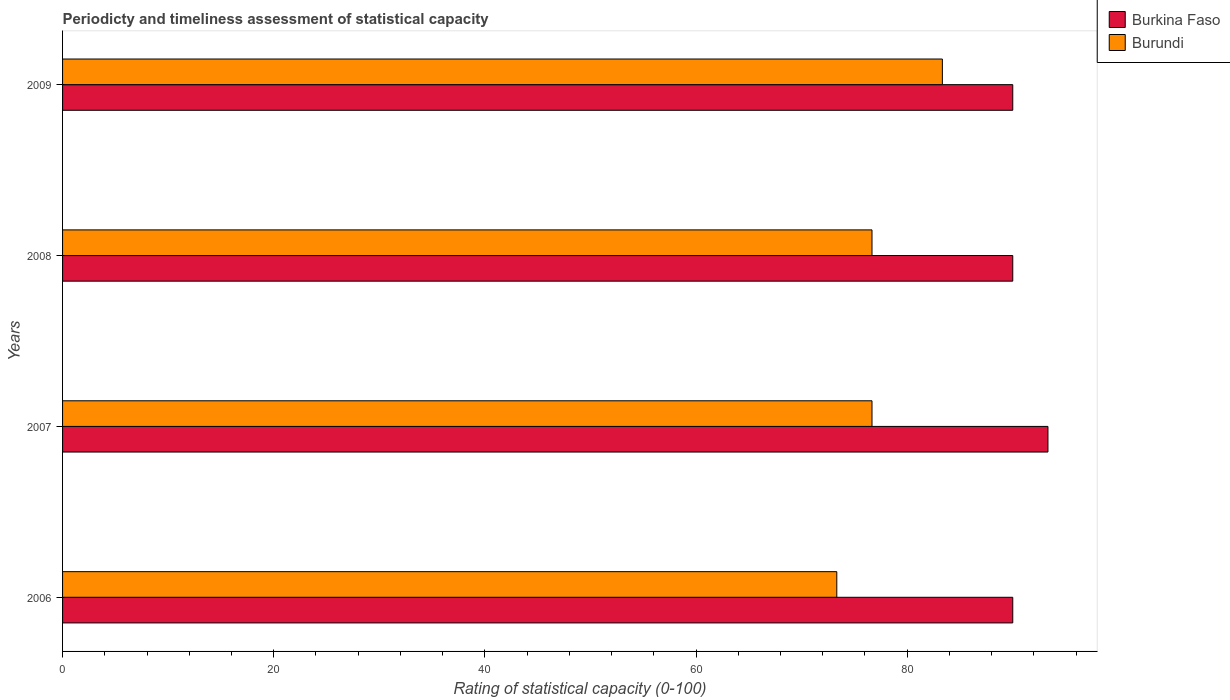How many groups of bars are there?
Your answer should be compact. 4. How many bars are there on the 3rd tick from the top?
Offer a terse response. 2. How many bars are there on the 4th tick from the bottom?
Provide a succinct answer. 2. What is the label of the 2nd group of bars from the top?
Offer a very short reply. 2008. In how many cases, is the number of bars for a given year not equal to the number of legend labels?
Provide a succinct answer. 0. Across all years, what is the maximum rating of statistical capacity in Burkina Faso?
Your response must be concise. 93.33. In which year was the rating of statistical capacity in Burkina Faso maximum?
Provide a short and direct response. 2007. What is the total rating of statistical capacity in Burkina Faso in the graph?
Provide a short and direct response. 363.33. What is the difference between the rating of statistical capacity in Burkina Faso in 2008 and that in 2009?
Keep it short and to the point. 0. What is the difference between the rating of statistical capacity in Burundi in 2008 and the rating of statistical capacity in Burkina Faso in 2007?
Give a very brief answer. -16.67. What is the average rating of statistical capacity in Burkina Faso per year?
Give a very brief answer. 90.83. In the year 2009, what is the difference between the rating of statistical capacity in Burundi and rating of statistical capacity in Burkina Faso?
Offer a terse response. -6.67. In how many years, is the rating of statistical capacity in Burundi greater than 76 ?
Your response must be concise. 3. What is the ratio of the rating of statistical capacity in Burundi in 2008 to that in 2009?
Offer a terse response. 0.92. Is the difference between the rating of statistical capacity in Burundi in 2007 and 2009 greater than the difference between the rating of statistical capacity in Burkina Faso in 2007 and 2009?
Give a very brief answer. No. What is the difference between the highest and the second highest rating of statistical capacity in Burundi?
Your answer should be very brief. 6.67. What is the difference between the highest and the lowest rating of statistical capacity in Burkina Faso?
Make the answer very short. 3.33. What does the 2nd bar from the top in 2006 represents?
Your response must be concise. Burkina Faso. What does the 2nd bar from the bottom in 2008 represents?
Provide a succinct answer. Burundi. Does the graph contain any zero values?
Your response must be concise. No. Does the graph contain grids?
Your answer should be compact. No. Where does the legend appear in the graph?
Make the answer very short. Top right. How many legend labels are there?
Your answer should be very brief. 2. What is the title of the graph?
Make the answer very short. Periodicty and timeliness assessment of statistical capacity. What is the label or title of the X-axis?
Keep it short and to the point. Rating of statistical capacity (0-100). What is the label or title of the Y-axis?
Provide a short and direct response. Years. What is the Rating of statistical capacity (0-100) of Burkina Faso in 2006?
Your answer should be very brief. 90. What is the Rating of statistical capacity (0-100) of Burundi in 2006?
Your answer should be compact. 73.33. What is the Rating of statistical capacity (0-100) in Burkina Faso in 2007?
Your response must be concise. 93.33. What is the Rating of statistical capacity (0-100) of Burundi in 2007?
Provide a succinct answer. 76.67. What is the Rating of statistical capacity (0-100) of Burkina Faso in 2008?
Your response must be concise. 90. What is the Rating of statistical capacity (0-100) in Burundi in 2008?
Your answer should be very brief. 76.67. What is the Rating of statistical capacity (0-100) of Burundi in 2009?
Provide a succinct answer. 83.33. Across all years, what is the maximum Rating of statistical capacity (0-100) in Burkina Faso?
Your answer should be compact. 93.33. Across all years, what is the maximum Rating of statistical capacity (0-100) in Burundi?
Keep it short and to the point. 83.33. Across all years, what is the minimum Rating of statistical capacity (0-100) of Burkina Faso?
Your answer should be very brief. 90. Across all years, what is the minimum Rating of statistical capacity (0-100) in Burundi?
Your answer should be very brief. 73.33. What is the total Rating of statistical capacity (0-100) in Burkina Faso in the graph?
Offer a terse response. 363.33. What is the total Rating of statistical capacity (0-100) of Burundi in the graph?
Your answer should be compact. 310. What is the difference between the Rating of statistical capacity (0-100) in Burkina Faso in 2006 and that in 2007?
Your response must be concise. -3.33. What is the difference between the Rating of statistical capacity (0-100) of Burkina Faso in 2006 and that in 2008?
Your answer should be very brief. 0. What is the difference between the Rating of statistical capacity (0-100) in Burundi in 2006 and that in 2008?
Ensure brevity in your answer.  -3.33. What is the difference between the Rating of statistical capacity (0-100) of Burkina Faso in 2006 and that in 2009?
Your response must be concise. 0. What is the difference between the Rating of statistical capacity (0-100) in Burkina Faso in 2007 and that in 2008?
Ensure brevity in your answer.  3.33. What is the difference between the Rating of statistical capacity (0-100) of Burundi in 2007 and that in 2008?
Make the answer very short. 0. What is the difference between the Rating of statistical capacity (0-100) of Burundi in 2007 and that in 2009?
Ensure brevity in your answer.  -6.67. What is the difference between the Rating of statistical capacity (0-100) of Burundi in 2008 and that in 2009?
Ensure brevity in your answer.  -6.67. What is the difference between the Rating of statistical capacity (0-100) of Burkina Faso in 2006 and the Rating of statistical capacity (0-100) of Burundi in 2007?
Offer a terse response. 13.33. What is the difference between the Rating of statistical capacity (0-100) of Burkina Faso in 2006 and the Rating of statistical capacity (0-100) of Burundi in 2008?
Your response must be concise. 13.33. What is the difference between the Rating of statistical capacity (0-100) of Burkina Faso in 2006 and the Rating of statistical capacity (0-100) of Burundi in 2009?
Your answer should be compact. 6.67. What is the difference between the Rating of statistical capacity (0-100) in Burkina Faso in 2007 and the Rating of statistical capacity (0-100) in Burundi in 2008?
Provide a succinct answer. 16.67. What is the difference between the Rating of statistical capacity (0-100) of Burkina Faso in 2008 and the Rating of statistical capacity (0-100) of Burundi in 2009?
Your answer should be very brief. 6.67. What is the average Rating of statistical capacity (0-100) of Burkina Faso per year?
Give a very brief answer. 90.83. What is the average Rating of statistical capacity (0-100) of Burundi per year?
Your answer should be very brief. 77.5. In the year 2006, what is the difference between the Rating of statistical capacity (0-100) of Burkina Faso and Rating of statistical capacity (0-100) of Burundi?
Your response must be concise. 16.67. In the year 2007, what is the difference between the Rating of statistical capacity (0-100) of Burkina Faso and Rating of statistical capacity (0-100) of Burundi?
Provide a succinct answer. 16.67. In the year 2008, what is the difference between the Rating of statistical capacity (0-100) in Burkina Faso and Rating of statistical capacity (0-100) in Burundi?
Provide a succinct answer. 13.33. What is the ratio of the Rating of statistical capacity (0-100) of Burundi in 2006 to that in 2007?
Your response must be concise. 0.96. What is the ratio of the Rating of statistical capacity (0-100) in Burundi in 2006 to that in 2008?
Give a very brief answer. 0.96. What is the ratio of the Rating of statistical capacity (0-100) in Burundi in 2006 to that in 2009?
Keep it short and to the point. 0.88. What is the ratio of the Rating of statistical capacity (0-100) in Burundi in 2007 to that in 2008?
Give a very brief answer. 1. What is the ratio of the Rating of statistical capacity (0-100) of Burundi in 2007 to that in 2009?
Your answer should be very brief. 0.92. What is the ratio of the Rating of statistical capacity (0-100) in Burundi in 2008 to that in 2009?
Your answer should be very brief. 0.92. What is the difference between the highest and the lowest Rating of statistical capacity (0-100) in Burkina Faso?
Keep it short and to the point. 3.33. What is the difference between the highest and the lowest Rating of statistical capacity (0-100) in Burundi?
Provide a short and direct response. 10. 